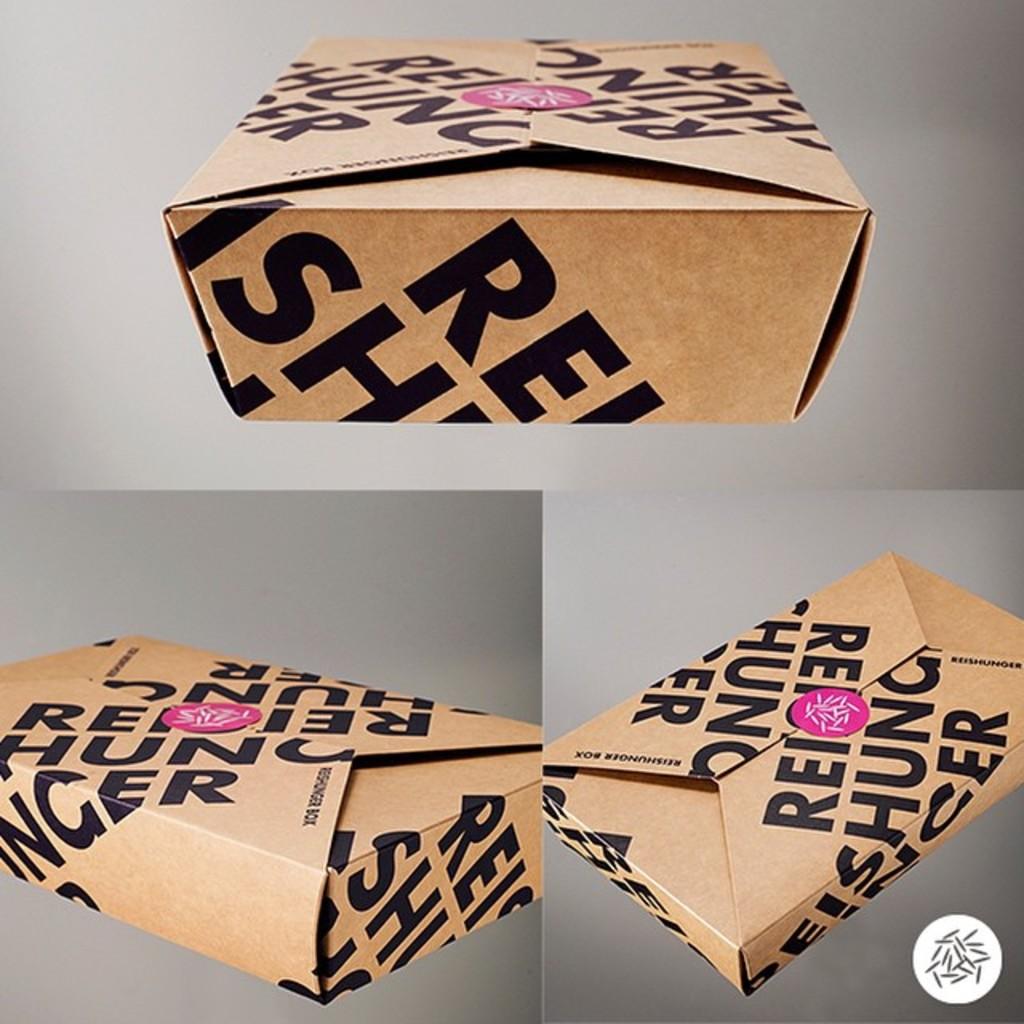What letter does the word start with?
Provide a succinct answer. R. 